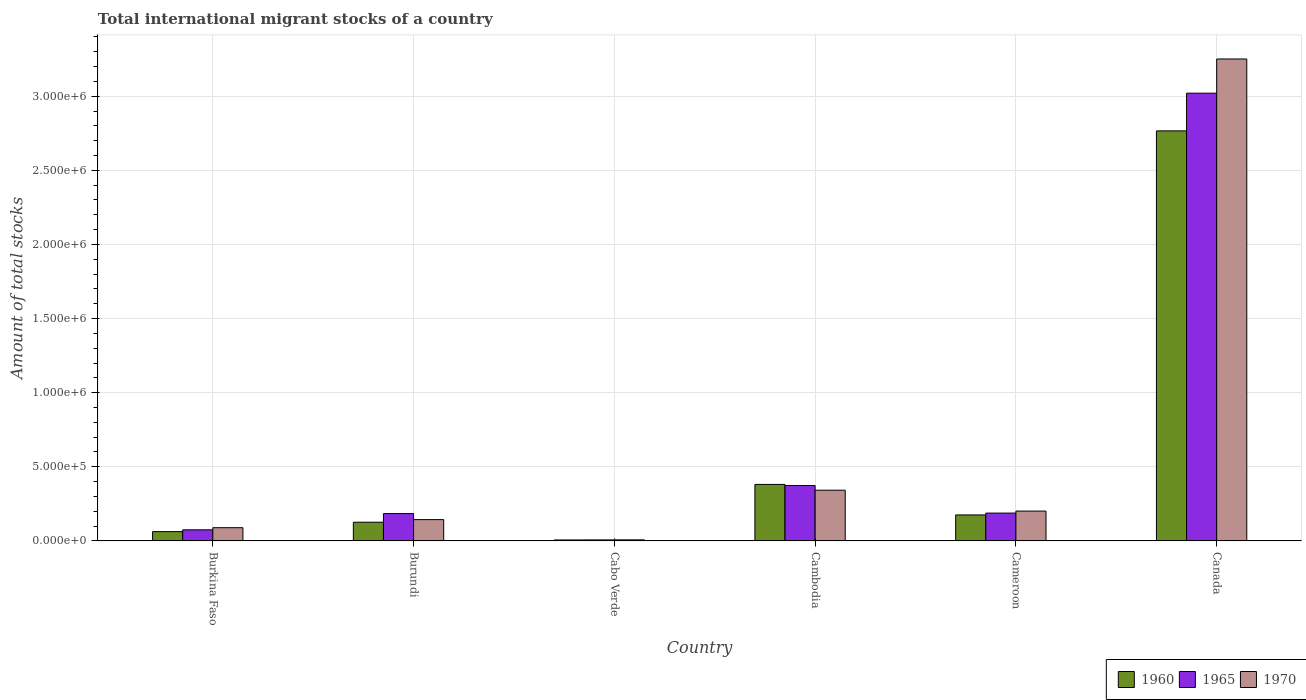How many different coloured bars are there?
Your answer should be compact. 3. How many groups of bars are there?
Offer a terse response. 6. Are the number of bars on each tick of the X-axis equal?
Offer a terse response. Yes. How many bars are there on the 5th tick from the left?
Provide a short and direct response. 3. What is the label of the 4th group of bars from the left?
Your answer should be compact. Cambodia. What is the amount of total stocks in in 1965 in Cabo Verde?
Provide a succinct answer. 6953. Across all countries, what is the maximum amount of total stocks in in 1965?
Ensure brevity in your answer.  3.02e+06. Across all countries, what is the minimum amount of total stocks in in 1965?
Your answer should be compact. 6953. In which country was the amount of total stocks in in 1970 minimum?
Your answer should be very brief. Cabo Verde. What is the total amount of total stocks in in 1960 in the graph?
Ensure brevity in your answer.  3.52e+06. What is the difference between the amount of total stocks in in 1970 in Burkina Faso and that in Cabo Verde?
Offer a terse response. 8.20e+04. What is the difference between the amount of total stocks in in 1965 in Burkina Faso and the amount of total stocks in in 1960 in Canada?
Ensure brevity in your answer.  -2.69e+06. What is the average amount of total stocks in in 1960 per country?
Give a very brief answer. 5.86e+05. What is the difference between the amount of total stocks in of/in 1965 and amount of total stocks in of/in 1970 in Burkina Faso?
Make the answer very short. -1.43e+04. What is the ratio of the amount of total stocks in in 1965 in Burkina Faso to that in Cabo Verde?
Your answer should be very brief. 10.78. What is the difference between the highest and the second highest amount of total stocks in in 1965?
Provide a succinct answer. 2.65e+06. What is the difference between the highest and the lowest amount of total stocks in in 1970?
Give a very brief answer. 3.24e+06. In how many countries, is the amount of total stocks in in 1960 greater than the average amount of total stocks in in 1960 taken over all countries?
Provide a short and direct response. 1. What does the 1st bar from the right in Canada represents?
Keep it short and to the point. 1970. Is it the case that in every country, the sum of the amount of total stocks in in 1960 and amount of total stocks in in 1970 is greater than the amount of total stocks in in 1965?
Make the answer very short. Yes. Are all the bars in the graph horizontal?
Offer a terse response. No. How many countries are there in the graph?
Your response must be concise. 6. What is the difference between two consecutive major ticks on the Y-axis?
Your answer should be very brief. 5.00e+05. Are the values on the major ticks of Y-axis written in scientific E-notation?
Your answer should be compact. Yes. Does the graph contain any zero values?
Give a very brief answer. No. Does the graph contain grids?
Make the answer very short. Yes. How are the legend labels stacked?
Your answer should be compact. Horizontal. What is the title of the graph?
Offer a terse response. Total international migrant stocks of a country. Does "1977" appear as one of the legend labels in the graph?
Your answer should be very brief. No. What is the label or title of the Y-axis?
Make the answer very short. Amount of total stocks. What is the Amount of total stocks in 1960 in Burkina Faso?
Keep it short and to the point. 6.29e+04. What is the Amount of total stocks in 1965 in Burkina Faso?
Your answer should be compact. 7.50e+04. What is the Amount of total stocks of 1970 in Burkina Faso?
Your answer should be compact. 8.93e+04. What is the Amount of total stocks of 1960 in Burundi?
Provide a short and direct response. 1.26e+05. What is the Amount of total stocks of 1965 in Burundi?
Keep it short and to the point. 1.85e+05. What is the Amount of total stocks in 1970 in Burundi?
Ensure brevity in your answer.  1.44e+05. What is the Amount of total stocks of 1960 in Cabo Verde?
Offer a very short reply. 6613. What is the Amount of total stocks in 1965 in Cabo Verde?
Your answer should be very brief. 6953. What is the Amount of total stocks in 1970 in Cabo Verde?
Offer a very short reply. 7310. What is the Amount of total stocks of 1960 in Cambodia?
Your answer should be very brief. 3.81e+05. What is the Amount of total stocks of 1965 in Cambodia?
Provide a succinct answer. 3.74e+05. What is the Amount of total stocks in 1970 in Cambodia?
Offer a very short reply. 3.42e+05. What is the Amount of total stocks in 1960 in Cameroon?
Provide a short and direct response. 1.75e+05. What is the Amount of total stocks in 1965 in Cameroon?
Provide a short and direct response. 1.88e+05. What is the Amount of total stocks in 1970 in Cameroon?
Give a very brief answer. 2.01e+05. What is the Amount of total stocks of 1960 in Canada?
Offer a terse response. 2.77e+06. What is the Amount of total stocks in 1965 in Canada?
Provide a short and direct response. 3.02e+06. What is the Amount of total stocks of 1970 in Canada?
Your answer should be compact. 3.25e+06. Across all countries, what is the maximum Amount of total stocks of 1960?
Offer a terse response. 2.77e+06. Across all countries, what is the maximum Amount of total stocks in 1965?
Ensure brevity in your answer.  3.02e+06. Across all countries, what is the maximum Amount of total stocks of 1970?
Your answer should be very brief. 3.25e+06. Across all countries, what is the minimum Amount of total stocks in 1960?
Your answer should be very brief. 6613. Across all countries, what is the minimum Amount of total stocks in 1965?
Provide a short and direct response. 6953. Across all countries, what is the minimum Amount of total stocks in 1970?
Provide a succinct answer. 7310. What is the total Amount of total stocks of 1960 in the graph?
Keep it short and to the point. 3.52e+06. What is the total Amount of total stocks in 1965 in the graph?
Keep it short and to the point. 3.85e+06. What is the total Amount of total stocks in 1970 in the graph?
Keep it short and to the point. 4.04e+06. What is the difference between the Amount of total stocks in 1960 in Burkina Faso and that in Burundi?
Provide a short and direct response. -6.34e+04. What is the difference between the Amount of total stocks of 1965 in Burkina Faso and that in Burundi?
Offer a very short reply. -1.10e+05. What is the difference between the Amount of total stocks of 1970 in Burkina Faso and that in Burundi?
Your answer should be compact. -5.45e+04. What is the difference between the Amount of total stocks of 1960 in Burkina Faso and that in Cabo Verde?
Your answer should be compact. 5.63e+04. What is the difference between the Amount of total stocks of 1965 in Burkina Faso and that in Cabo Verde?
Keep it short and to the point. 6.80e+04. What is the difference between the Amount of total stocks in 1970 in Burkina Faso and that in Cabo Verde?
Your answer should be very brief. 8.20e+04. What is the difference between the Amount of total stocks of 1960 in Burkina Faso and that in Cambodia?
Your answer should be very brief. -3.18e+05. What is the difference between the Amount of total stocks of 1965 in Burkina Faso and that in Cambodia?
Your answer should be very brief. -2.99e+05. What is the difference between the Amount of total stocks of 1970 in Burkina Faso and that in Cambodia?
Keep it short and to the point. -2.53e+05. What is the difference between the Amount of total stocks of 1960 in Burkina Faso and that in Cameroon?
Ensure brevity in your answer.  -1.12e+05. What is the difference between the Amount of total stocks of 1965 in Burkina Faso and that in Cameroon?
Offer a terse response. -1.13e+05. What is the difference between the Amount of total stocks in 1970 in Burkina Faso and that in Cameroon?
Provide a succinct answer. -1.12e+05. What is the difference between the Amount of total stocks in 1960 in Burkina Faso and that in Canada?
Keep it short and to the point. -2.70e+06. What is the difference between the Amount of total stocks of 1965 in Burkina Faso and that in Canada?
Your answer should be very brief. -2.95e+06. What is the difference between the Amount of total stocks in 1970 in Burkina Faso and that in Canada?
Give a very brief answer. -3.16e+06. What is the difference between the Amount of total stocks in 1960 in Burundi and that in Cabo Verde?
Keep it short and to the point. 1.20e+05. What is the difference between the Amount of total stocks in 1965 in Burundi and that in Cabo Verde?
Your response must be concise. 1.78e+05. What is the difference between the Amount of total stocks of 1970 in Burundi and that in Cabo Verde?
Keep it short and to the point. 1.37e+05. What is the difference between the Amount of total stocks in 1960 in Burundi and that in Cambodia?
Ensure brevity in your answer.  -2.55e+05. What is the difference between the Amount of total stocks of 1965 in Burundi and that in Cambodia?
Keep it short and to the point. -1.89e+05. What is the difference between the Amount of total stocks in 1970 in Burundi and that in Cambodia?
Your answer should be very brief. -1.99e+05. What is the difference between the Amount of total stocks in 1960 in Burundi and that in Cameroon?
Your answer should be very brief. -4.91e+04. What is the difference between the Amount of total stocks in 1965 in Burundi and that in Cameroon?
Make the answer very short. -3323. What is the difference between the Amount of total stocks of 1970 in Burundi and that in Cameroon?
Provide a short and direct response. -5.76e+04. What is the difference between the Amount of total stocks in 1960 in Burundi and that in Canada?
Your answer should be compact. -2.64e+06. What is the difference between the Amount of total stocks of 1965 in Burundi and that in Canada?
Offer a very short reply. -2.84e+06. What is the difference between the Amount of total stocks in 1970 in Burundi and that in Canada?
Keep it short and to the point. -3.11e+06. What is the difference between the Amount of total stocks in 1960 in Cabo Verde and that in Cambodia?
Provide a succinct answer. -3.75e+05. What is the difference between the Amount of total stocks of 1965 in Cabo Verde and that in Cambodia?
Your response must be concise. -3.67e+05. What is the difference between the Amount of total stocks of 1970 in Cabo Verde and that in Cambodia?
Give a very brief answer. -3.35e+05. What is the difference between the Amount of total stocks in 1960 in Cabo Verde and that in Cameroon?
Your answer should be compact. -1.69e+05. What is the difference between the Amount of total stocks of 1965 in Cabo Verde and that in Cameroon?
Ensure brevity in your answer.  -1.81e+05. What is the difference between the Amount of total stocks of 1970 in Cabo Verde and that in Cameroon?
Offer a terse response. -1.94e+05. What is the difference between the Amount of total stocks in 1960 in Cabo Verde and that in Canada?
Keep it short and to the point. -2.76e+06. What is the difference between the Amount of total stocks in 1965 in Cabo Verde and that in Canada?
Keep it short and to the point. -3.01e+06. What is the difference between the Amount of total stocks in 1970 in Cabo Verde and that in Canada?
Give a very brief answer. -3.24e+06. What is the difference between the Amount of total stocks in 1960 in Cambodia and that in Cameroon?
Keep it short and to the point. 2.06e+05. What is the difference between the Amount of total stocks of 1965 in Cambodia and that in Cameroon?
Provide a short and direct response. 1.86e+05. What is the difference between the Amount of total stocks in 1970 in Cambodia and that in Cameroon?
Offer a terse response. 1.41e+05. What is the difference between the Amount of total stocks in 1960 in Cambodia and that in Canada?
Your answer should be compact. -2.39e+06. What is the difference between the Amount of total stocks in 1965 in Cambodia and that in Canada?
Provide a succinct answer. -2.65e+06. What is the difference between the Amount of total stocks of 1970 in Cambodia and that in Canada?
Your answer should be compact. -2.91e+06. What is the difference between the Amount of total stocks in 1960 in Cameroon and that in Canada?
Offer a very short reply. -2.59e+06. What is the difference between the Amount of total stocks in 1965 in Cameroon and that in Canada?
Your answer should be compact. -2.83e+06. What is the difference between the Amount of total stocks in 1970 in Cameroon and that in Canada?
Your answer should be very brief. -3.05e+06. What is the difference between the Amount of total stocks in 1960 in Burkina Faso and the Amount of total stocks in 1965 in Burundi?
Offer a terse response. -1.22e+05. What is the difference between the Amount of total stocks in 1960 in Burkina Faso and the Amount of total stocks in 1970 in Burundi?
Provide a succinct answer. -8.09e+04. What is the difference between the Amount of total stocks in 1965 in Burkina Faso and the Amount of total stocks in 1970 in Burundi?
Provide a short and direct response. -6.88e+04. What is the difference between the Amount of total stocks in 1960 in Burkina Faso and the Amount of total stocks in 1965 in Cabo Verde?
Make the answer very short. 5.60e+04. What is the difference between the Amount of total stocks in 1960 in Burkina Faso and the Amount of total stocks in 1970 in Cabo Verde?
Your answer should be very brief. 5.56e+04. What is the difference between the Amount of total stocks in 1965 in Burkina Faso and the Amount of total stocks in 1970 in Cabo Verde?
Offer a terse response. 6.77e+04. What is the difference between the Amount of total stocks in 1960 in Burkina Faso and the Amount of total stocks in 1965 in Cambodia?
Ensure brevity in your answer.  -3.11e+05. What is the difference between the Amount of total stocks of 1960 in Burkina Faso and the Amount of total stocks of 1970 in Cambodia?
Keep it short and to the point. -2.79e+05. What is the difference between the Amount of total stocks in 1965 in Burkina Faso and the Amount of total stocks in 1970 in Cambodia?
Provide a short and direct response. -2.67e+05. What is the difference between the Amount of total stocks in 1960 in Burkina Faso and the Amount of total stocks in 1965 in Cameroon?
Your answer should be compact. -1.25e+05. What is the difference between the Amount of total stocks in 1960 in Burkina Faso and the Amount of total stocks in 1970 in Cameroon?
Keep it short and to the point. -1.38e+05. What is the difference between the Amount of total stocks in 1965 in Burkina Faso and the Amount of total stocks in 1970 in Cameroon?
Make the answer very short. -1.26e+05. What is the difference between the Amount of total stocks in 1960 in Burkina Faso and the Amount of total stocks in 1965 in Canada?
Provide a short and direct response. -2.96e+06. What is the difference between the Amount of total stocks of 1960 in Burkina Faso and the Amount of total stocks of 1970 in Canada?
Give a very brief answer. -3.19e+06. What is the difference between the Amount of total stocks of 1965 in Burkina Faso and the Amount of total stocks of 1970 in Canada?
Your answer should be very brief. -3.18e+06. What is the difference between the Amount of total stocks of 1960 in Burundi and the Amount of total stocks of 1965 in Cabo Verde?
Your answer should be compact. 1.19e+05. What is the difference between the Amount of total stocks in 1960 in Burundi and the Amount of total stocks in 1970 in Cabo Verde?
Your response must be concise. 1.19e+05. What is the difference between the Amount of total stocks of 1965 in Burundi and the Amount of total stocks of 1970 in Cabo Verde?
Keep it short and to the point. 1.77e+05. What is the difference between the Amount of total stocks of 1960 in Burundi and the Amount of total stocks of 1965 in Cambodia?
Keep it short and to the point. -2.47e+05. What is the difference between the Amount of total stocks in 1960 in Burundi and the Amount of total stocks in 1970 in Cambodia?
Ensure brevity in your answer.  -2.16e+05. What is the difference between the Amount of total stocks of 1965 in Burundi and the Amount of total stocks of 1970 in Cambodia?
Your response must be concise. -1.58e+05. What is the difference between the Amount of total stocks in 1960 in Burundi and the Amount of total stocks in 1965 in Cameroon?
Your answer should be very brief. -6.16e+04. What is the difference between the Amount of total stocks of 1960 in Burundi and the Amount of total stocks of 1970 in Cameroon?
Provide a succinct answer. -7.51e+04. What is the difference between the Amount of total stocks of 1965 in Burundi and the Amount of total stocks of 1970 in Cameroon?
Make the answer very short. -1.67e+04. What is the difference between the Amount of total stocks of 1960 in Burundi and the Amount of total stocks of 1965 in Canada?
Offer a very short reply. -2.89e+06. What is the difference between the Amount of total stocks of 1960 in Burundi and the Amount of total stocks of 1970 in Canada?
Your response must be concise. -3.13e+06. What is the difference between the Amount of total stocks of 1965 in Burundi and the Amount of total stocks of 1970 in Canada?
Give a very brief answer. -3.07e+06. What is the difference between the Amount of total stocks of 1960 in Cabo Verde and the Amount of total stocks of 1965 in Cambodia?
Give a very brief answer. -3.67e+05. What is the difference between the Amount of total stocks of 1960 in Cabo Verde and the Amount of total stocks of 1970 in Cambodia?
Keep it short and to the point. -3.36e+05. What is the difference between the Amount of total stocks of 1965 in Cabo Verde and the Amount of total stocks of 1970 in Cambodia?
Your answer should be very brief. -3.35e+05. What is the difference between the Amount of total stocks of 1960 in Cabo Verde and the Amount of total stocks of 1965 in Cameroon?
Your answer should be compact. -1.81e+05. What is the difference between the Amount of total stocks in 1960 in Cabo Verde and the Amount of total stocks in 1970 in Cameroon?
Your answer should be compact. -1.95e+05. What is the difference between the Amount of total stocks of 1965 in Cabo Verde and the Amount of total stocks of 1970 in Cameroon?
Offer a terse response. -1.94e+05. What is the difference between the Amount of total stocks of 1960 in Cabo Verde and the Amount of total stocks of 1965 in Canada?
Ensure brevity in your answer.  -3.01e+06. What is the difference between the Amount of total stocks of 1960 in Cabo Verde and the Amount of total stocks of 1970 in Canada?
Ensure brevity in your answer.  -3.24e+06. What is the difference between the Amount of total stocks of 1965 in Cabo Verde and the Amount of total stocks of 1970 in Canada?
Make the answer very short. -3.24e+06. What is the difference between the Amount of total stocks in 1960 in Cambodia and the Amount of total stocks in 1965 in Cameroon?
Your answer should be very brief. 1.93e+05. What is the difference between the Amount of total stocks in 1960 in Cambodia and the Amount of total stocks in 1970 in Cameroon?
Provide a short and direct response. 1.80e+05. What is the difference between the Amount of total stocks in 1965 in Cambodia and the Amount of total stocks in 1970 in Cameroon?
Offer a very short reply. 1.72e+05. What is the difference between the Amount of total stocks of 1960 in Cambodia and the Amount of total stocks of 1965 in Canada?
Provide a short and direct response. -2.64e+06. What is the difference between the Amount of total stocks of 1960 in Cambodia and the Amount of total stocks of 1970 in Canada?
Keep it short and to the point. -2.87e+06. What is the difference between the Amount of total stocks of 1965 in Cambodia and the Amount of total stocks of 1970 in Canada?
Ensure brevity in your answer.  -2.88e+06. What is the difference between the Amount of total stocks of 1960 in Cameroon and the Amount of total stocks of 1965 in Canada?
Offer a very short reply. -2.85e+06. What is the difference between the Amount of total stocks of 1960 in Cameroon and the Amount of total stocks of 1970 in Canada?
Give a very brief answer. -3.08e+06. What is the difference between the Amount of total stocks of 1965 in Cameroon and the Amount of total stocks of 1970 in Canada?
Your answer should be very brief. -3.06e+06. What is the average Amount of total stocks of 1960 per country?
Your response must be concise. 5.86e+05. What is the average Amount of total stocks of 1965 per country?
Make the answer very short. 6.41e+05. What is the average Amount of total stocks in 1970 per country?
Provide a short and direct response. 6.73e+05. What is the difference between the Amount of total stocks of 1960 and Amount of total stocks of 1965 in Burkina Faso?
Your response must be concise. -1.20e+04. What is the difference between the Amount of total stocks in 1960 and Amount of total stocks in 1970 in Burkina Faso?
Your answer should be compact. -2.64e+04. What is the difference between the Amount of total stocks in 1965 and Amount of total stocks in 1970 in Burkina Faso?
Give a very brief answer. -1.43e+04. What is the difference between the Amount of total stocks of 1960 and Amount of total stocks of 1965 in Burundi?
Ensure brevity in your answer.  -5.83e+04. What is the difference between the Amount of total stocks in 1960 and Amount of total stocks in 1970 in Burundi?
Give a very brief answer. -1.75e+04. What is the difference between the Amount of total stocks of 1965 and Amount of total stocks of 1970 in Burundi?
Provide a short and direct response. 4.08e+04. What is the difference between the Amount of total stocks of 1960 and Amount of total stocks of 1965 in Cabo Verde?
Provide a short and direct response. -340. What is the difference between the Amount of total stocks of 1960 and Amount of total stocks of 1970 in Cabo Verde?
Keep it short and to the point. -697. What is the difference between the Amount of total stocks of 1965 and Amount of total stocks of 1970 in Cabo Verde?
Make the answer very short. -357. What is the difference between the Amount of total stocks of 1960 and Amount of total stocks of 1965 in Cambodia?
Offer a terse response. 7646. What is the difference between the Amount of total stocks in 1960 and Amount of total stocks in 1970 in Cambodia?
Make the answer very short. 3.89e+04. What is the difference between the Amount of total stocks of 1965 and Amount of total stocks of 1970 in Cambodia?
Provide a short and direct response. 3.13e+04. What is the difference between the Amount of total stocks in 1960 and Amount of total stocks in 1965 in Cameroon?
Offer a terse response. -1.25e+04. What is the difference between the Amount of total stocks in 1960 and Amount of total stocks in 1970 in Cameroon?
Keep it short and to the point. -2.59e+04. What is the difference between the Amount of total stocks in 1965 and Amount of total stocks in 1970 in Cameroon?
Ensure brevity in your answer.  -1.34e+04. What is the difference between the Amount of total stocks in 1960 and Amount of total stocks in 1965 in Canada?
Offer a terse response. -2.54e+05. What is the difference between the Amount of total stocks of 1960 and Amount of total stocks of 1970 in Canada?
Offer a very short reply. -4.85e+05. What is the difference between the Amount of total stocks of 1965 and Amount of total stocks of 1970 in Canada?
Keep it short and to the point. -2.31e+05. What is the ratio of the Amount of total stocks of 1960 in Burkina Faso to that in Burundi?
Keep it short and to the point. 0.5. What is the ratio of the Amount of total stocks of 1965 in Burkina Faso to that in Burundi?
Provide a short and direct response. 0.41. What is the ratio of the Amount of total stocks of 1970 in Burkina Faso to that in Burundi?
Make the answer very short. 0.62. What is the ratio of the Amount of total stocks in 1960 in Burkina Faso to that in Cabo Verde?
Ensure brevity in your answer.  9.52. What is the ratio of the Amount of total stocks of 1965 in Burkina Faso to that in Cabo Verde?
Keep it short and to the point. 10.78. What is the ratio of the Amount of total stocks in 1970 in Burkina Faso to that in Cabo Verde?
Provide a succinct answer. 12.22. What is the ratio of the Amount of total stocks in 1960 in Burkina Faso to that in Cambodia?
Provide a short and direct response. 0.17. What is the ratio of the Amount of total stocks in 1965 in Burkina Faso to that in Cambodia?
Provide a succinct answer. 0.2. What is the ratio of the Amount of total stocks in 1970 in Burkina Faso to that in Cambodia?
Provide a succinct answer. 0.26. What is the ratio of the Amount of total stocks in 1960 in Burkina Faso to that in Cameroon?
Provide a short and direct response. 0.36. What is the ratio of the Amount of total stocks of 1965 in Burkina Faso to that in Cameroon?
Your answer should be very brief. 0.4. What is the ratio of the Amount of total stocks of 1970 in Burkina Faso to that in Cameroon?
Provide a short and direct response. 0.44. What is the ratio of the Amount of total stocks of 1960 in Burkina Faso to that in Canada?
Your answer should be compact. 0.02. What is the ratio of the Amount of total stocks of 1965 in Burkina Faso to that in Canada?
Make the answer very short. 0.02. What is the ratio of the Amount of total stocks in 1970 in Burkina Faso to that in Canada?
Offer a terse response. 0.03. What is the ratio of the Amount of total stocks in 1960 in Burundi to that in Cabo Verde?
Your answer should be compact. 19.1. What is the ratio of the Amount of total stocks of 1965 in Burundi to that in Cabo Verde?
Give a very brief answer. 26.55. What is the ratio of the Amount of total stocks of 1970 in Burundi to that in Cabo Verde?
Offer a terse response. 19.67. What is the ratio of the Amount of total stocks of 1960 in Burundi to that in Cambodia?
Offer a terse response. 0.33. What is the ratio of the Amount of total stocks in 1965 in Burundi to that in Cambodia?
Make the answer very short. 0.49. What is the ratio of the Amount of total stocks of 1970 in Burundi to that in Cambodia?
Make the answer very short. 0.42. What is the ratio of the Amount of total stocks in 1960 in Burundi to that in Cameroon?
Offer a very short reply. 0.72. What is the ratio of the Amount of total stocks in 1965 in Burundi to that in Cameroon?
Your answer should be compact. 0.98. What is the ratio of the Amount of total stocks in 1970 in Burundi to that in Cameroon?
Give a very brief answer. 0.71. What is the ratio of the Amount of total stocks in 1960 in Burundi to that in Canada?
Your answer should be very brief. 0.05. What is the ratio of the Amount of total stocks in 1965 in Burundi to that in Canada?
Provide a succinct answer. 0.06. What is the ratio of the Amount of total stocks in 1970 in Burundi to that in Canada?
Your answer should be compact. 0.04. What is the ratio of the Amount of total stocks of 1960 in Cabo Verde to that in Cambodia?
Your response must be concise. 0.02. What is the ratio of the Amount of total stocks in 1965 in Cabo Verde to that in Cambodia?
Your response must be concise. 0.02. What is the ratio of the Amount of total stocks in 1970 in Cabo Verde to that in Cambodia?
Your answer should be very brief. 0.02. What is the ratio of the Amount of total stocks of 1960 in Cabo Verde to that in Cameroon?
Ensure brevity in your answer.  0.04. What is the ratio of the Amount of total stocks in 1965 in Cabo Verde to that in Cameroon?
Provide a short and direct response. 0.04. What is the ratio of the Amount of total stocks in 1970 in Cabo Verde to that in Cameroon?
Keep it short and to the point. 0.04. What is the ratio of the Amount of total stocks in 1960 in Cabo Verde to that in Canada?
Your response must be concise. 0. What is the ratio of the Amount of total stocks in 1965 in Cabo Verde to that in Canada?
Make the answer very short. 0. What is the ratio of the Amount of total stocks of 1970 in Cabo Verde to that in Canada?
Make the answer very short. 0. What is the ratio of the Amount of total stocks in 1960 in Cambodia to that in Cameroon?
Give a very brief answer. 2.17. What is the ratio of the Amount of total stocks in 1965 in Cambodia to that in Cameroon?
Your response must be concise. 1.99. What is the ratio of the Amount of total stocks in 1970 in Cambodia to that in Cameroon?
Offer a very short reply. 1.7. What is the ratio of the Amount of total stocks in 1960 in Cambodia to that in Canada?
Ensure brevity in your answer.  0.14. What is the ratio of the Amount of total stocks in 1965 in Cambodia to that in Canada?
Keep it short and to the point. 0.12. What is the ratio of the Amount of total stocks of 1970 in Cambodia to that in Canada?
Provide a succinct answer. 0.11. What is the ratio of the Amount of total stocks of 1960 in Cameroon to that in Canada?
Give a very brief answer. 0.06. What is the ratio of the Amount of total stocks in 1965 in Cameroon to that in Canada?
Your response must be concise. 0.06. What is the ratio of the Amount of total stocks of 1970 in Cameroon to that in Canada?
Your answer should be very brief. 0.06. What is the difference between the highest and the second highest Amount of total stocks of 1960?
Make the answer very short. 2.39e+06. What is the difference between the highest and the second highest Amount of total stocks of 1965?
Ensure brevity in your answer.  2.65e+06. What is the difference between the highest and the second highest Amount of total stocks in 1970?
Give a very brief answer. 2.91e+06. What is the difference between the highest and the lowest Amount of total stocks of 1960?
Provide a succinct answer. 2.76e+06. What is the difference between the highest and the lowest Amount of total stocks in 1965?
Your answer should be very brief. 3.01e+06. What is the difference between the highest and the lowest Amount of total stocks of 1970?
Give a very brief answer. 3.24e+06. 